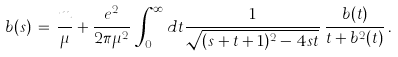<formula> <loc_0><loc_0><loc_500><loc_500>b ( s ) \, = \, \frac { m } { \mu } + \frac { e ^ { 2 } } { 2 \pi \mu ^ { 2 } } \, \int _ { 0 } ^ { \infty } d t \frac { 1 } { \sqrt { ( s + t + 1 ) ^ { 2 } - 4 s t } } \, \frac { b ( t ) } { t + b ^ { 2 } ( t ) } \, .</formula> 